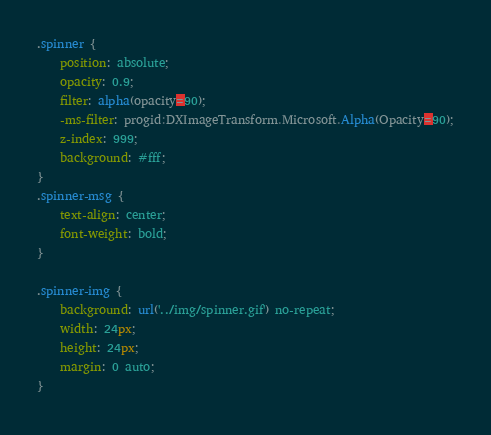<code> <loc_0><loc_0><loc_500><loc_500><_CSS_>.spinner {
	position: absolute;
	opacity: 0.9;
	filter: alpha(opacity=90);
	-ms-filter: progid:DXImageTransform.Microsoft.Alpha(Opacity=90);
	z-index: 999;
	background: #fff;
}
.spinner-msg {
	text-align: center;
	font-weight: bold;
}

.spinner-img {
	background: url('../img/spinner.gif') no-repeat;
	width: 24px;
	height: 24px;
	margin: 0 auto;
}
</code> 